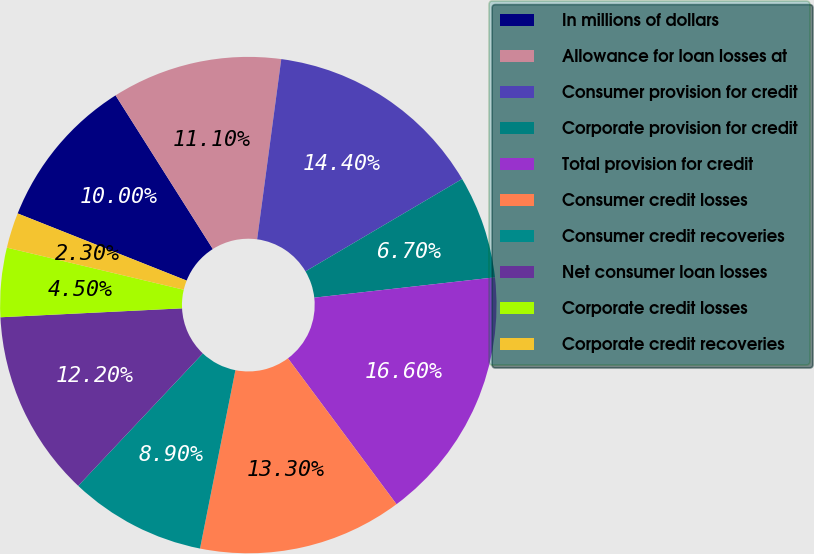Convert chart. <chart><loc_0><loc_0><loc_500><loc_500><pie_chart><fcel>In millions of dollars<fcel>Allowance for loan losses at<fcel>Consumer provision for credit<fcel>Corporate provision for credit<fcel>Total provision for credit<fcel>Consumer credit losses<fcel>Consumer credit recoveries<fcel>Net consumer loan losses<fcel>Corporate credit losses<fcel>Corporate credit recoveries<nl><fcel>10.0%<fcel>11.1%<fcel>14.4%<fcel>6.7%<fcel>16.6%<fcel>13.3%<fcel>8.9%<fcel>12.2%<fcel>4.5%<fcel>2.3%<nl></chart> 